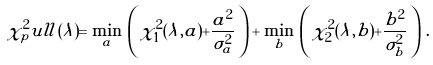<formula> <loc_0><loc_0><loc_500><loc_500>\chi ^ { 2 } _ { p } u l l ( \lambda ) = \min _ { a } \, \left ( \, \chi _ { 1 } ^ { 2 } ( \lambda , a ) + \frac { a ^ { 2 } } { \sigma _ { a } ^ { 2 } } \, \right ) + \min _ { b } \, \left ( \, \chi _ { 2 } ^ { 2 } ( \lambda , b ) + \frac { b ^ { 2 } } { \sigma _ { b } ^ { 2 } } \, \right ) \, .</formula> 